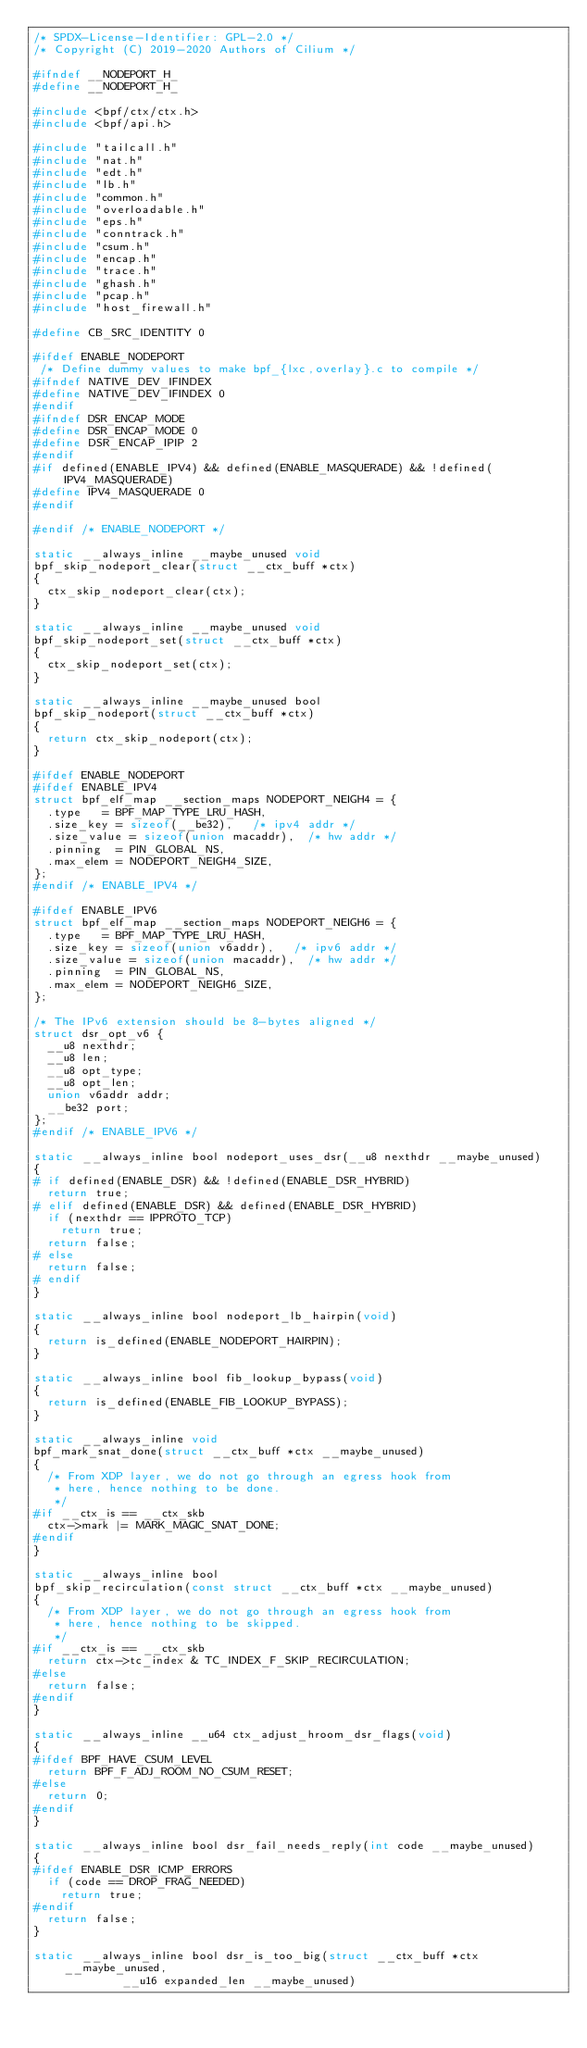Convert code to text. <code><loc_0><loc_0><loc_500><loc_500><_C_>/* SPDX-License-Identifier: GPL-2.0 */
/* Copyright (C) 2019-2020 Authors of Cilium */

#ifndef __NODEPORT_H_
#define __NODEPORT_H_

#include <bpf/ctx/ctx.h>
#include <bpf/api.h>

#include "tailcall.h"
#include "nat.h"
#include "edt.h"
#include "lb.h"
#include "common.h"
#include "overloadable.h"
#include "eps.h"
#include "conntrack.h"
#include "csum.h"
#include "encap.h"
#include "trace.h"
#include "ghash.h"
#include "pcap.h"
#include "host_firewall.h"

#define CB_SRC_IDENTITY	0

#ifdef ENABLE_NODEPORT
 /* Define dummy values to make bpf_{lxc,overlay}.c to compile */
#ifndef NATIVE_DEV_IFINDEX
#define NATIVE_DEV_IFINDEX 0
#endif
#ifndef DSR_ENCAP_MODE
#define DSR_ENCAP_MODE 0
#define DSR_ENCAP_IPIP 2
#endif
#if defined(ENABLE_IPV4) && defined(ENABLE_MASQUERADE) && !defined(IPV4_MASQUERADE)
#define IPV4_MASQUERADE 0
#endif

#endif /* ENABLE_NODEPORT */

static __always_inline __maybe_unused void
bpf_skip_nodeport_clear(struct __ctx_buff *ctx)
{
	ctx_skip_nodeport_clear(ctx);
}

static __always_inline __maybe_unused void
bpf_skip_nodeport_set(struct __ctx_buff *ctx)
{
	ctx_skip_nodeport_set(ctx);
}

static __always_inline __maybe_unused bool
bpf_skip_nodeport(struct __ctx_buff *ctx)
{
	return ctx_skip_nodeport(ctx);
}

#ifdef ENABLE_NODEPORT
#ifdef ENABLE_IPV4
struct bpf_elf_map __section_maps NODEPORT_NEIGH4 = {
	.type		= BPF_MAP_TYPE_LRU_HASH,
	.size_key	= sizeof(__be32),		/* ipv4 addr */
	.size_value	= sizeof(union macaddr),	/* hw addr */
	.pinning	= PIN_GLOBAL_NS,
	.max_elem	= NODEPORT_NEIGH4_SIZE,
};
#endif /* ENABLE_IPV4 */

#ifdef ENABLE_IPV6
struct bpf_elf_map __section_maps NODEPORT_NEIGH6 = {
	.type		= BPF_MAP_TYPE_LRU_HASH,
	.size_key	= sizeof(union v6addr),		/* ipv6 addr */
	.size_value	= sizeof(union macaddr),	/* hw addr */
	.pinning	= PIN_GLOBAL_NS,
	.max_elem	= NODEPORT_NEIGH6_SIZE,
};

/* The IPv6 extension should be 8-bytes aligned */
struct dsr_opt_v6 {
	__u8 nexthdr;
	__u8 len;
	__u8 opt_type;
	__u8 opt_len;
	union v6addr addr;
	__be32 port;
};
#endif /* ENABLE_IPV6 */

static __always_inline bool nodeport_uses_dsr(__u8 nexthdr __maybe_unused)
{
# if defined(ENABLE_DSR) && !defined(ENABLE_DSR_HYBRID)
	return true;
# elif defined(ENABLE_DSR) && defined(ENABLE_DSR_HYBRID)
	if (nexthdr == IPPROTO_TCP)
		return true;
	return false;
# else
	return false;
# endif
}

static __always_inline bool nodeport_lb_hairpin(void)
{
	return is_defined(ENABLE_NODEPORT_HAIRPIN);
}

static __always_inline bool fib_lookup_bypass(void)
{
	return is_defined(ENABLE_FIB_LOOKUP_BYPASS);
}

static __always_inline void
bpf_mark_snat_done(struct __ctx_buff *ctx __maybe_unused)
{
	/* From XDP layer, we do not go through an egress hook from
	 * here, hence nothing to be done.
	 */
#if __ctx_is == __ctx_skb
	ctx->mark |= MARK_MAGIC_SNAT_DONE;
#endif
}

static __always_inline bool
bpf_skip_recirculation(const struct __ctx_buff *ctx __maybe_unused)
{
	/* From XDP layer, we do not go through an egress hook from
	 * here, hence nothing to be skipped.
	 */
#if __ctx_is == __ctx_skb
	return ctx->tc_index & TC_INDEX_F_SKIP_RECIRCULATION;
#else
	return false;
#endif
}

static __always_inline __u64 ctx_adjust_hroom_dsr_flags(void)
{
#ifdef BPF_HAVE_CSUM_LEVEL
	return BPF_F_ADJ_ROOM_NO_CSUM_RESET;
#else
	return 0;
#endif
}

static __always_inline bool dsr_fail_needs_reply(int code __maybe_unused)
{
#ifdef ENABLE_DSR_ICMP_ERRORS
	if (code == DROP_FRAG_NEEDED)
		return true;
#endif
	return false;
}

static __always_inline bool dsr_is_too_big(struct __ctx_buff *ctx __maybe_unused,
					   __u16 expanded_len __maybe_unused)</code> 